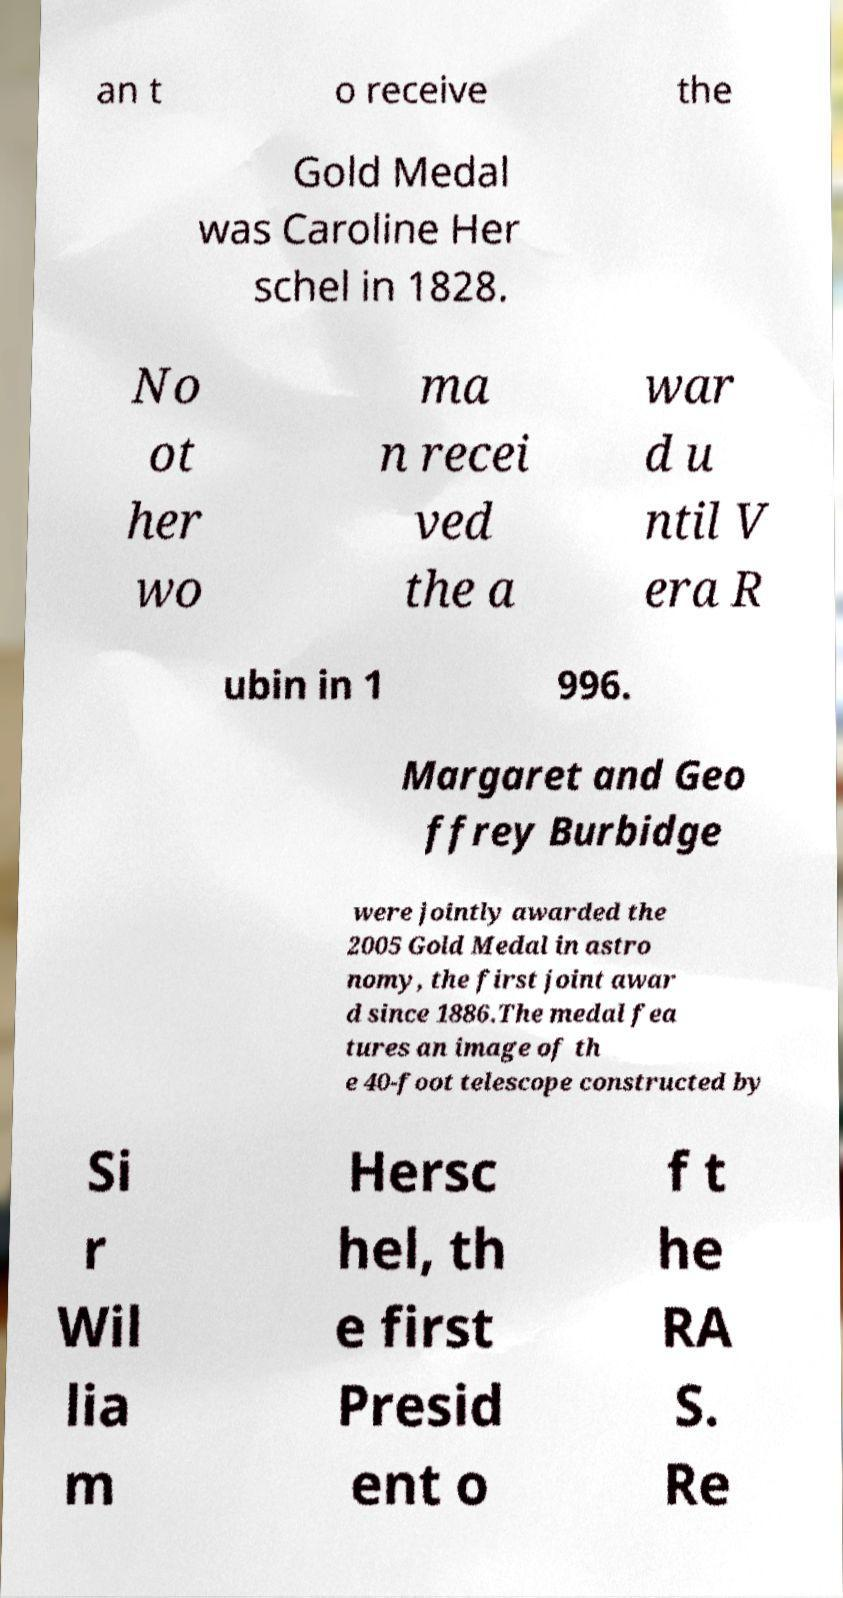I need the written content from this picture converted into text. Can you do that? an t o receive the Gold Medal was Caroline Her schel in 1828. No ot her wo ma n recei ved the a war d u ntil V era R ubin in 1 996. Margaret and Geo ffrey Burbidge were jointly awarded the 2005 Gold Medal in astro nomy, the first joint awar d since 1886.The medal fea tures an image of th e 40-foot telescope constructed by Si r Wil lia m Hersc hel, th e first Presid ent o f t he RA S. Re 